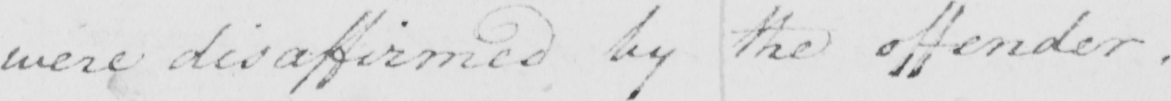What does this handwritten line say? were disaffirmed by the offender . 